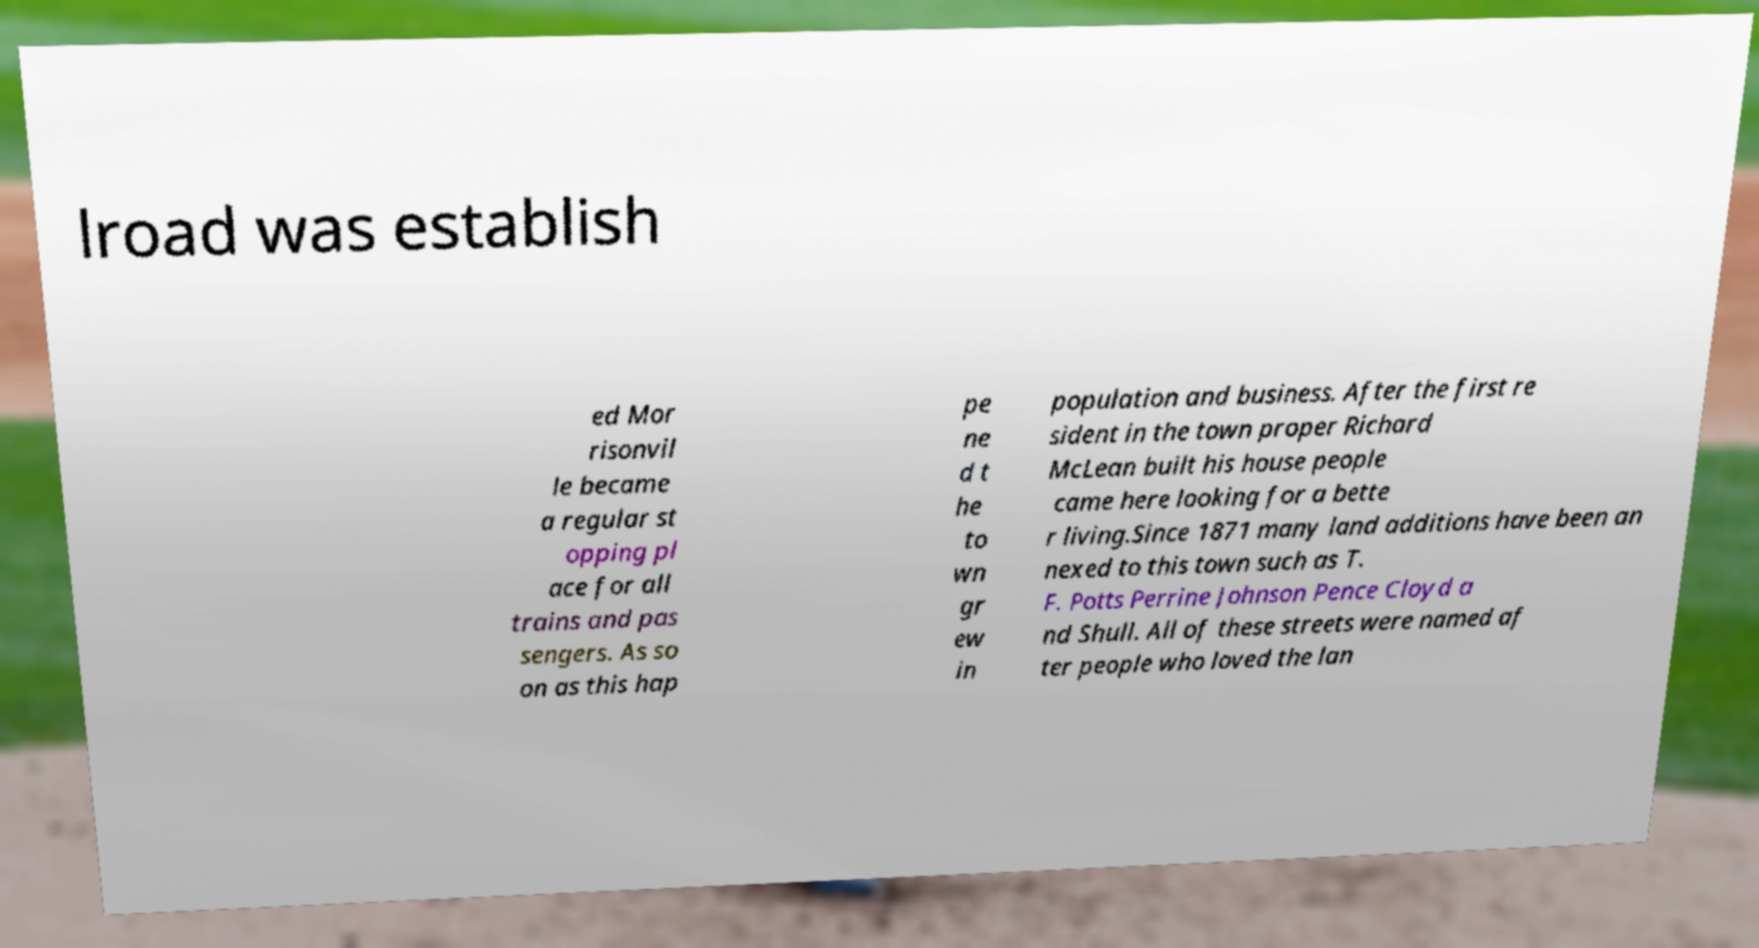Please read and relay the text visible in this image. What does it say? lroad was establish ed Mor risonvil le became a regular st opping pl ace for all trains and pas sengers. As so on as this hap pe ne d t he to wn gr ew in population and business. After the first re sident in the town proper Richard McLean built his house people came here looking for a bette r living.Since 1871 many land additions have been an nexed to this town such as T. F. Potts Perrine Johnson Pence Cloyd a nd Shull. All of these streets were named af ter people who loved the lan 